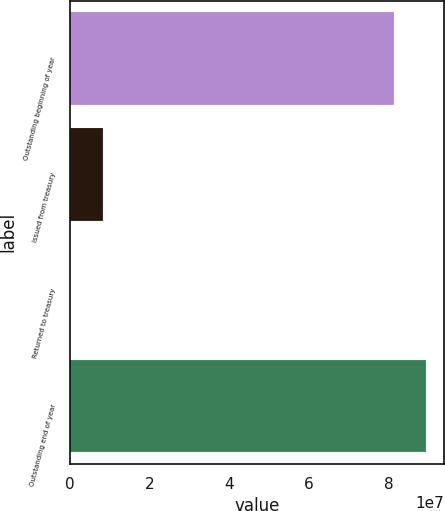<chart> <loc_0><loc_0><loc_500><loc_500><bar_chart><fcel>Outstanding beginning of year<fcel>Issued from treasury<fcel>Returned to treasury<fcel>Outstanding end of year<nl><fcel>8.12768e+07<fcel>8.25991e+06<fcel>21334<fcel>8.95154e+07<nl></chart> 